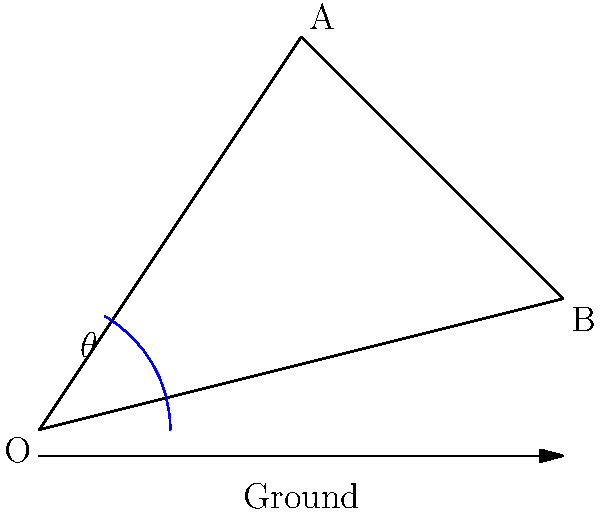As a baseball coach, you're analyzing the mechanics of a pitcher's arm motion. The diagram shows a simplified model of the pitcher's arm, where OA represents the upper arm and AB the forearm. If the angle $\theta$ between the ground and the upper arm is 60°, and OA = 2 units and AB = 3 units, what is the optimal angle $\alpha$ (in degrees) between the upper arm and forearm to maximize the velocity of the ball at release point B? To find the optimal angle for maximum velocity at point B, we need to follow these steps:

1) First, we need to understand that the velocity at point B will be maximized when the distance of B from O is maximized.

2) The distance OB can be calculated using the law of cosines:

   $OB^2 = OA^2 + AB^2 - 2(OA)(AB)\cos\alpha$

3) To maximize OB, we need to minimize $\cos\alpha$. The minimum value of cosine is -1, which occurs at 180°.

4) However, a 180° angle between the upper arm and forearm is not physically possible for a human. The maximum angle that can typically be achieved is around 165°.

5) Therefore, the optimal angle $\alpha$ for maximizing the ball's velocity at release would be approximately 165°.

6) It's important to note that this is a simplified model. In reality, the optimal angle might be slightly different due to factors like muscle mechanics, individual flexibility, and the specific pitch being thrown.

7) As a baseball coach, you would use this information as a general guideline, but would also need to consider each pitcher's individual mechanics and comfort.
Answer: Approximately 165° 